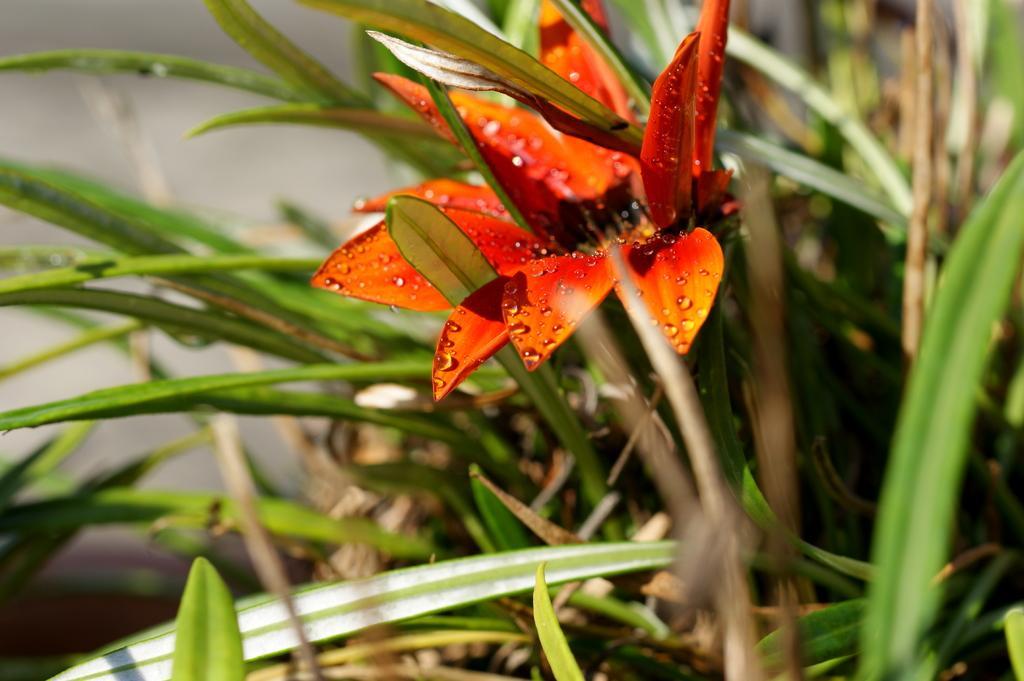Can you describe this image briefly? Here in this picture we can see a flower present on the plant over there. 